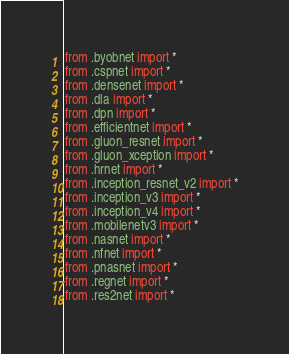Convert code to text. <code><loc_0><loc_0><loc_500><loc_500><_Python_>from .byobnet import *
from .cspnet import *
from .densenet import *
from .dla import *
from .dpn import *
from .efficientnet import *
from .gluon_resnet import *
from .gluon_xception import *
from .hrnet import *
from .inception_resnet_v2 import *
from .inception_v3 import *
from .inception_v4 import *
from .mobilenetv3 import *
from .nasnet import *
from .nfnet import *
from .pnasnet import *
from .regnet import *
from .res2net import *</code> 